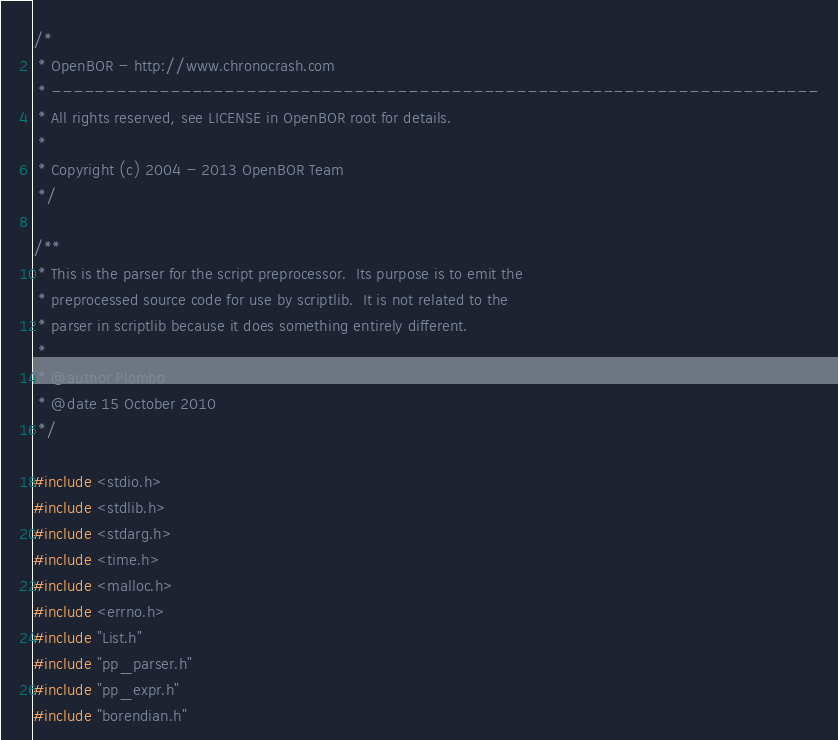Convert code to text. <code><loc_0><loc_0><loc_500><loc_500><_C_>/*
 * OpenBOR - http://www.chronocrash.com
 * -----------------------------------------------------------------------
 * All rights reserved, see LICENSE in OpenBOR root for details.
 *
 * Copyright (c) 2004 - 2013 OpenBOR Team
 */

/**
 * This is the parser for the script preprocessor.  Its purpose is to emit the
 * preprocessed source code for use by scriptlib.  It is not related to the
 * parser in scriptlib because it does something entirely different.
 *
 * @author Plombo
 * @date 15 October 2010
 */

#include <stdio.h>
#include <stdlib.h>
#include <stdarg.h>
#include <time.h>
#include <malloc.h>
#include <errno.h>
#include "List.h"
#include "pp_parser.h"
#include "pp_expr.h"
#include "borendian.h"
</code> 